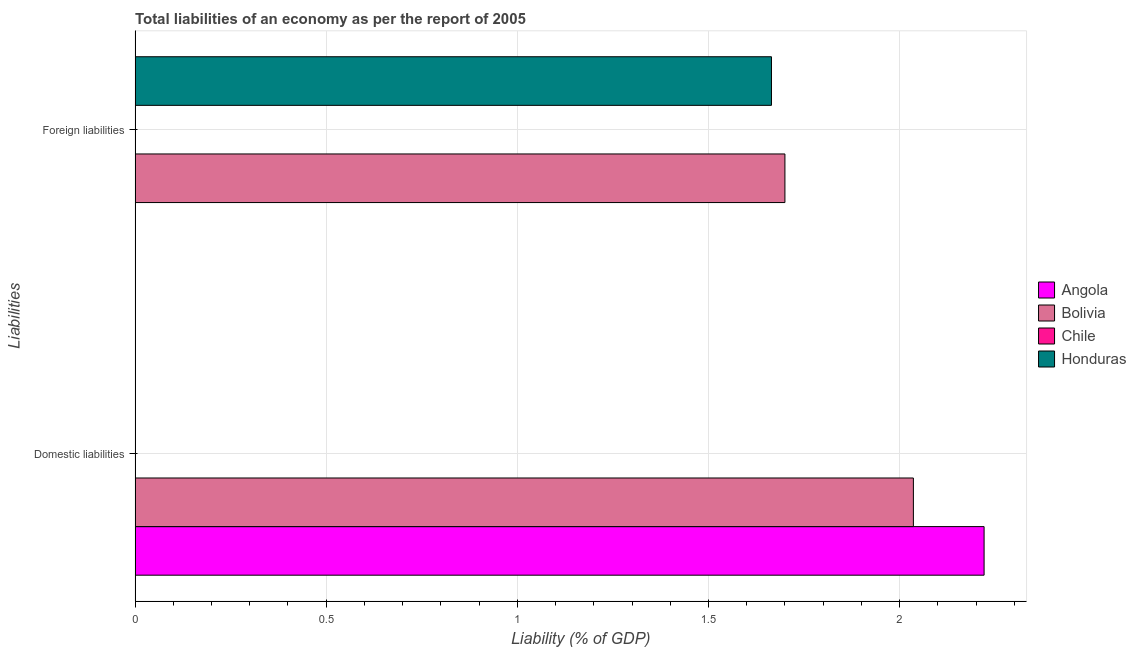How many different coloured bars are there?
Offer a very short reply. 3. How many groups of bars are there?
Your answer should be compact. 2. How many bars are there on the 1st tick from the bottom?
Make the answer very short. 2. What is the label of the 1st group of bars from the top?
Give a very brief answer. Foreign liabilities. What is the incurrence of domestic liabilities in Angola?
Provide a short and direct response. 2.22. Across all countries, what is the maximum incurrence of domestic liabilities?
Your answer should be very brief. 2.22. Across all countries, what is the minimum incurrence of domestic liabilities?
Your answer should be very brief. 0. In which country was the incurrence of domestic liabilities maximum?
Ensure brevity in your answer.  Angola. What is the total incurrence of foreign liabilities in the graph?
Ensure brevity in your answer.  3.36. What is the difference between the incurrence of domestic liabilities in Angola and that in Bolivia?
Offer a terse response. 0.18. What is the difference between the incurrence of foreign liabilities in Honduras and the incurrence of domestic liabilities in Angola?
Provide a short and direct response. -0.56. What is the average incurrence of foreign liabilities per country?
Offer a terse response. 0.84. What is the difference between the incurrence of domestic liabilities and incurrence of foreign liabilities in Bolivia?
Provide a short and direct response. 0.34. In how many countries, is the incurrence of domestic liabilities greater than 1.1 %?
Keep it short and to the point. 2. Is the incurrence of foreign liabilities in Bolivia less than that in Honduras?
Your answer should be very brief. No. In how many countries, is the incurrence of domestic liabilities greater than the average incurrence of domestic liabilities taken over all countries?
Keep it short and to the point. 2. How many bars are there?
Give a very brief answer. 4. What is the difference between two consecutive major ticks on the X-axis?
Make the answer very short. 0.5. Are the values on the major ticks of X-axis written in scientific E-notation?
Give a very brief answer. No. Does the graph contain any zero values?
Keep it short and to the point. Yes. What is the title of the graph?
Provide a succinct answer. Total liabilities of an economy as per the report of 2005. Does "Togo" appear as one of the legend labels in the graph?
Provide a succinct answer. No. What is the label or title of the X-axis?
Your response must be concise. Liability (% of GDP). What is the label or title of the Y-axis?
Provide a short and direct response. Liabilities. What is the Liability (% of GDP) of Angola in Domestic liabilities?
Offer a terse response. 2.22. What is the Liability (% of GDP) of Bolivia in Domestic liabilities?
Ensure brevity in your answer.  2.04. What is the Liability (% of GDP) in Honduras in Domestic liabilities?
Your answer should be very brief. 0. What is the Liability (% of GDP) in Angola in Foreign liabilities?
Offer a terse response. 0. What is the Liability (% of GDP) in Bolivia in Foreign liabilities?
Offer a terse response. 1.7. What is the Liability (% of GDP) in Chile in Foreign liabilities?
Your answer should be compact. 0. What is the Liability (% of GDP) in Honduras in Foreign liabilities?
Your answer should be compact. 1.66. Across all Liabilities, what is the maximum Liability (% of GDP) in Angola?
Your answer should be compact. 2.22. Across all Liabilities, what is the maximum Liability (% of GDP) of Bolivia?
Your response must be concise. 2.04. Across all Liabilities, what is the maximum Liability (% of GDP) in Honduras?
Make the answer very short. 1.66. Across all Liabilities, what is the minimum Liability (% of GDP) in Angola?
Provide a succinct answer. 0. Across all Liabilities, what is the minimum Liability (% of GDP) in Bolivia?
Provide a succinct answer. 1.7. What is the total Liability (% of GDP) of Angola in the graph?
Your response must be concise. 2.22. What is the total Liability (% of GDP) of Bolivia in the graph?
Your answer should be compact. 3.74. What is the total Liability (% of GDP) in Chile in the graph?
Ensure brevity in your answer.  0. What is the total Liability (% of GDP) in Honduras in the graph?
Your answer should be compact. 1.66. What is the difference between the Liability (% of GDP) of Bolivia in Domestic liabilities and that in Foreign liabilities?
Your answer should be compact. 0.34. What is the difference between the Liability (% of GDP) in Angola in Domestic liabilities and the Liability (% of GDP) in Bolivia in Foreign liabilities?
Your answer should be compact. 0.52. What is the difference between the Liability (% of GDP) of Angola in Domestic liabilities and the Liability (% of GDP) of Honduras in Foreign liabilities?
Offer a terse response. 0.56. What is the difference between the Liability (% of GDP) of Bolivia in Domestic liabilities and the Liability (% of GDP) of Honduras in Foreign liabilities?
Offer a terse response. 0.37. What is the average Liability (% of GDP) in Angola per Liabilities?
Offer a very short reply. 1.11. What is the average Liability (% of GDP) of Bolivia per Liabilities?
Your response must be concise. 1.87. What is the average Liability (% of GDP) in Chile per Liabilities?
Keep it short and to the point. 0. What is the average Liability (% of GDP) of Honduras per Liabilities?
Your answer should be compact. 0.83. What is the difference between the Liability (% of GDP) of Angola and Liability (% of GDP) of Bolivia in Domestic liabilities?
Offer a terse response. 0.18. What is the difference between the Liability (% of GDP) of Bolivia and Liability (% of GDP) of Honduras in Foreign liabilities?
Your response must be concise. 0.04. What is the ratio of the Liability (% of GDP) in Bolivia in Domestic liabilities to that in Foreign liabilities?
Provide a succinct answer. 1.2. What is the difference between the highest and the second highest Liability (% of GDP) of Bolivia?
Your answer should be very brief. 0.34. What is the difference between the highest and the lowest Liability (% of GDP) in Angola?
Offer a very short reply. 2.22. What is the difference between the highest and the lowest Liability (% of GDP) in Bolivia?
Make the answer very short. 0.34. What is the difference between the highest and the lowest Liability (% of GDP) in Honduras?
Offer a terse response. 1.66. 